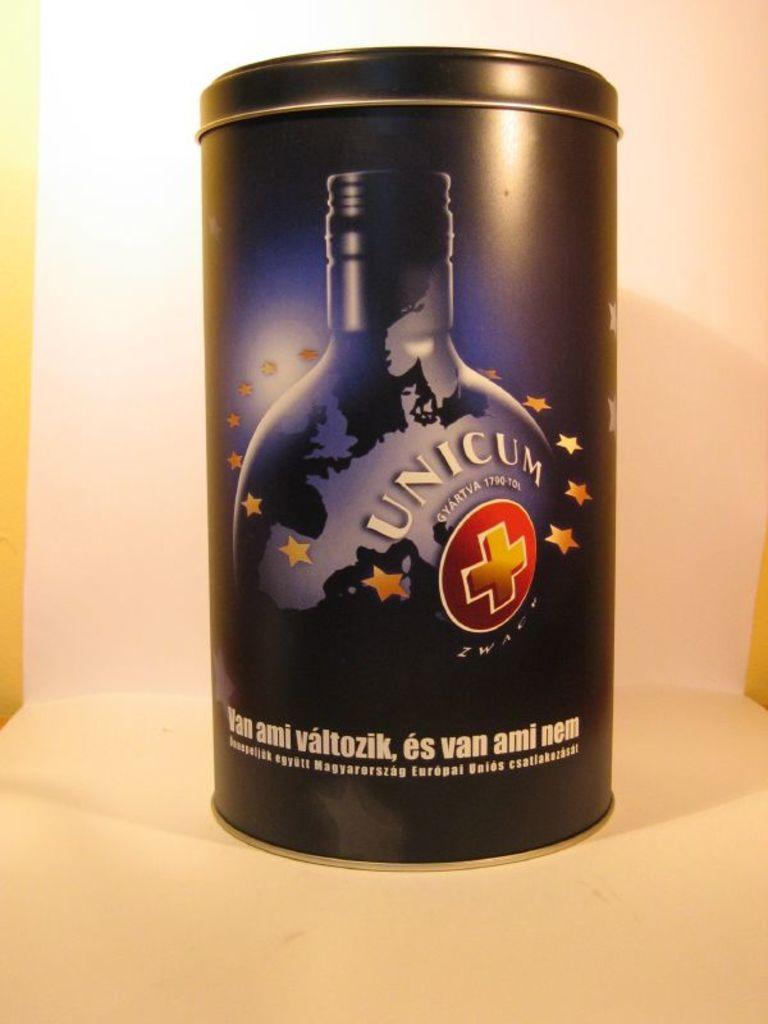What brand is this?
Keep it short and to the point. Unicum. What is the tagline?
Offer a very short reply. Van ami valtozik, es van ami nem. 